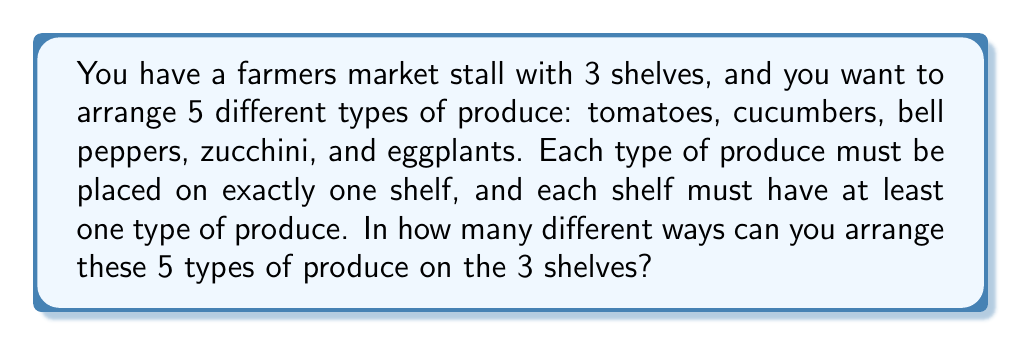Could you help me with this problem? Let's approach this step-by-step using the concept of Stirling numbers of the second kind and the multiplication principle:

1) First, we need to determine the number of ways to distribute 5 distinct items (produce types) into 3 non-empty, unlabeled sets (shelves). This is given by the Stirling number of the second kind, denoted as $\stirling{5}{3}$.

2) The formula for this Stirling number is:

   $$\stirling{5}{3} = \frac{1}{3!}\sum_{i=0}^3 (-1)^i \binom{3}{i}(3-i)^5$$

3) Expanding this:
   $$\stirling{5}{3} = \frac{1}{6}[(3^5) - 3(2^5) + 3(1^5) - 0]$$
   $$= \frac{1}{6}[243 - 96 + 3]$$
   $$= \frac{1}{6}[150] = 25$$

4) So there are 25 ways to distribute the produce among the shelves.

5) However, the shelves themselves are distinct (top, middle, bottom). For each of these 25 distributions, we can arrange the non-empty sets (1, 2, or 3) in 3! = 6 ways.

6) Therefore, the total number of arrangements is:

   $$25 \times 6 = 150$$
Answer: 150 